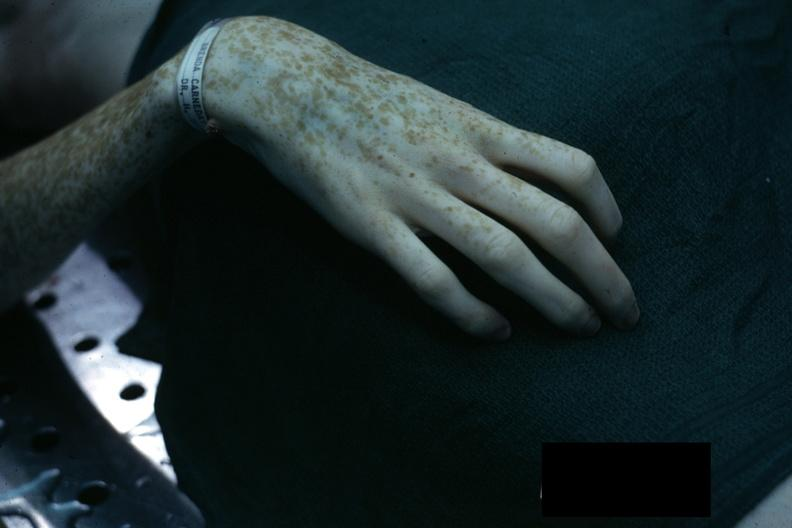s hand present?
Answer the question using a single word or phrase. Yes 